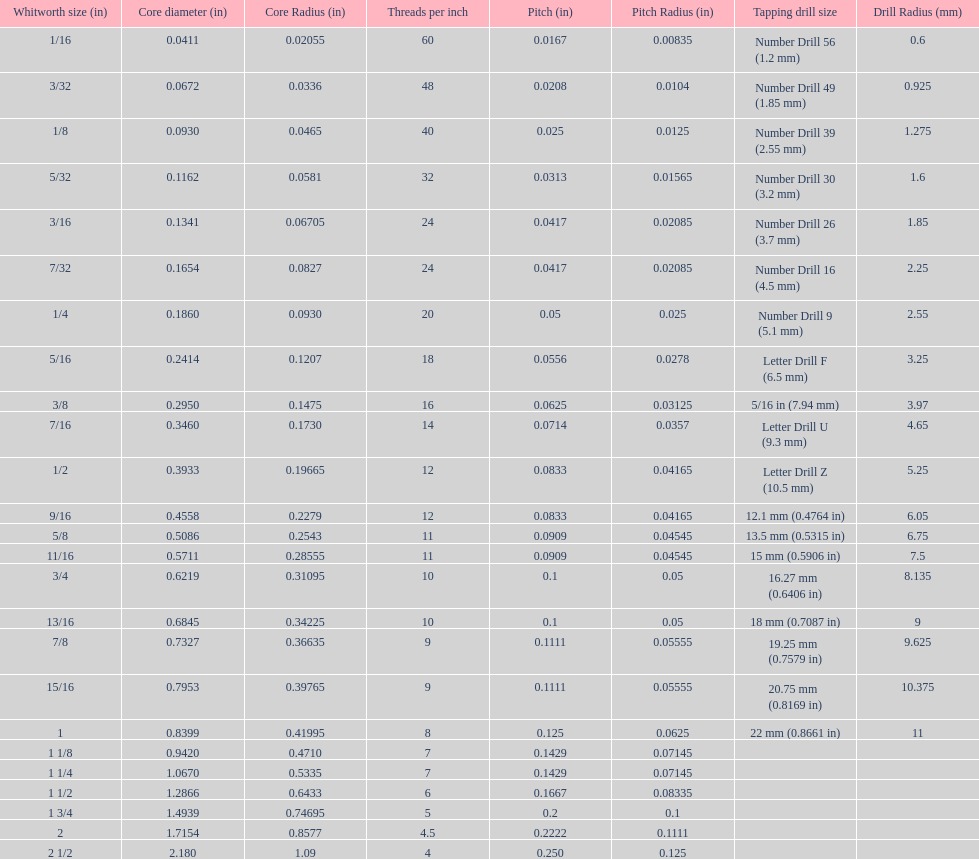Which whitworth size is the only one with 5 threads per inch? 1 3/4. 